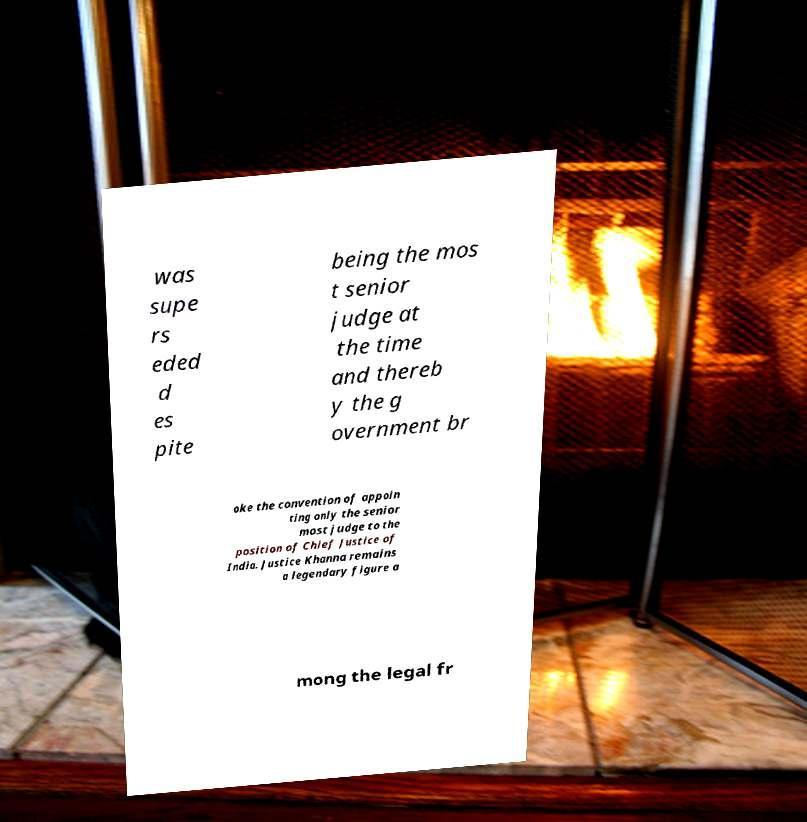I need the written content from this picture converted into text. Can you do that? was supe rs eded d es pite being the mos t senior judge at the time and thereb y the g overnment br oke the convention of appoin ting only the senior most judge to the position of Chief Justice of India. Justice Khanna remains a legendary figure a mong the legal fr 